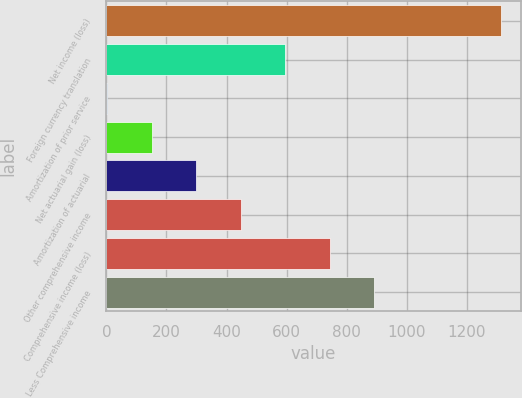Convert chart. <chart><loc_0><loc_0><loc_500><loc_500><bar_chart><fcel>Net income (loss)<fcel>Foreign currency translation<fcel>Amortization of prior service<fcel>Net actuarial gain (loss)<fcel>Amortization of actuarial<fcel>Other comprehensive income<fcel>Comprehensive income (loss)<fcel>Less Comprehensive income<nl><fcel>1314<fcel>595.8<fcel>3<fcel>151.2<fcel>299.4<fcel>447.6<fcel>744<fcel>892.2<nl></chart> 